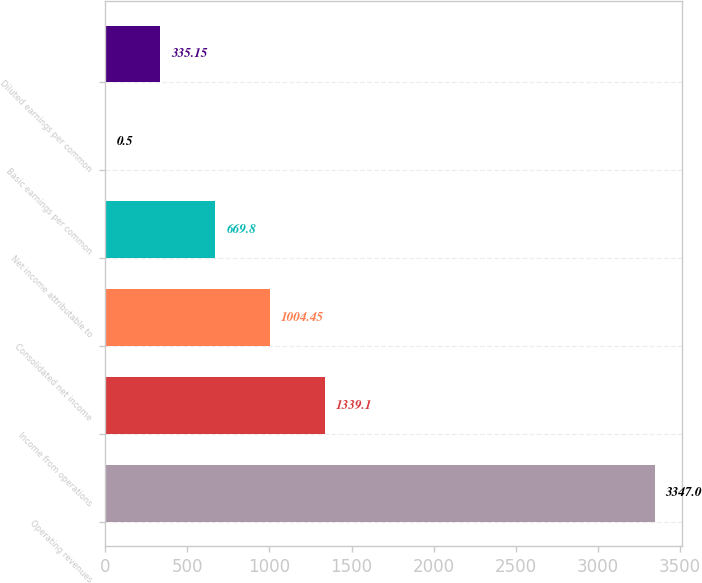Convert chart. <chart><loc_0><loc_0><loc_500><loc_500><bar_chart><fcel>Operating revenues<fcel>Income from operations<fcel>Consolidated net income<fcel>Net income attributable to<fcel>Basic earnings per common<fcel>Diluted earnings per common<nl><fcel>3347<fcel>1339.1<fcel>1004.45<fcel>669.8<fcel>0.5<fcel>335.15<nl></chart> 